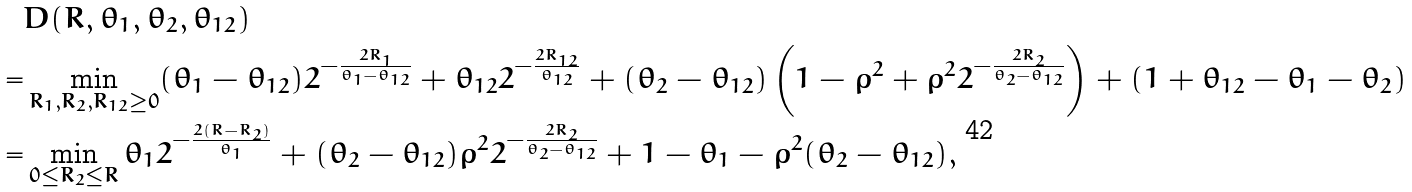Convert formula to latex. <formula><loc_0><loc_0><loc_500><loc_500>& D ( R , \theta _ { 1 } , \theta _ { 2 } , \theta _ { 1 2 } ) \\ = & \min _ { R _ { 1 } , R _ { 2 } , R _ { 1 2 } \geq 0 } ( \theta _ { 1 } - \theta _ { 1 2 } ) 2 ^ { - \frac { 2 R _ { 1 } } { \theta _ { 1 } - \theta _ { 1 2 } } } + \theta _ { 1 2 } 2 ^ { - \frac { 2 R _ { 1 2 } } { \theta _ { 1 2 } } } + ( \theta _ { 2 } - \theta _ { 1 2 } ) \left ( 1 - \rho ^ { 2 } + \rho ^ { 2 } 2 ^ { - \frac { 2 R _ { 2 } } { \theta _ { 2 } - \theta _ { 1 2 } } } \right ) + ( 1 + \theta _ { 1 2 } - \theta _ { 1 } - \theta _ { 2 } ) \\ = & \min _ { 0 \leq R _ { 2 } \leq R } \theta _ { 1 } 2 ^ { - \frac { 2 ( R - R _ { 2 } ) } { \theta _ { 1 } } } + ( \theta _ { 2 } - \theta _ { 1 2 } ) \rho ^ { 2 } 2 ^ { - \frac { 2 R _ { 2 } } { \theta _ { 2 } - \theta _ { 1 2 } } } + 1 - \theta _ { 1 } - \rho ^ { 2 } ( \theta _ { 2 } - \theta _ { 1 2 } ) ,</formula> 